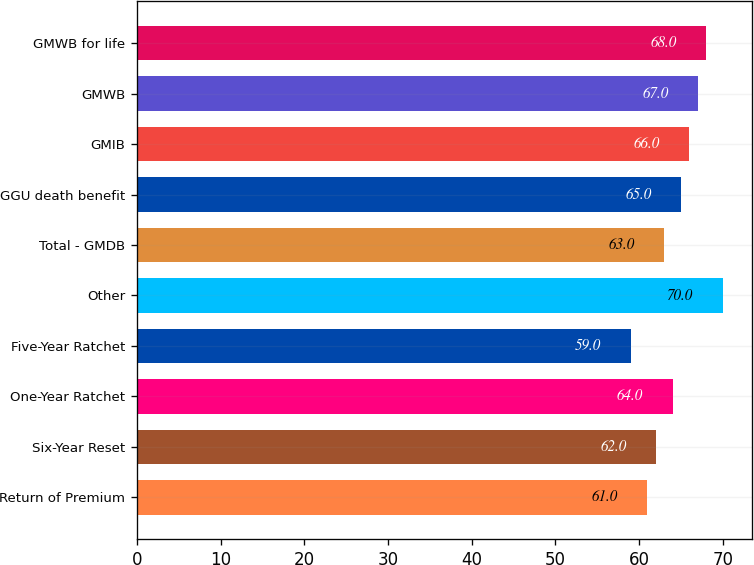<chart> <loc_0><loc_0><loc_500><loc_500><bar_chart><fcel>Return of Premium<fcel>Six-Year Reset<fcel>One-Year Ratchet<fcel>Five-Year Ratchet<fcel>Other<fcel>Total - GMDB<fcel>GGU death benefit<fcel>GMIB<fcel>GMWB<fcel>GMWB for life<nl><fcel>61<fcel>62<fcel>64<fcel>59<fcel>70<fcel>63<fcel>65<fcel>66<fcel>67<fcel>68<nl></chart> 